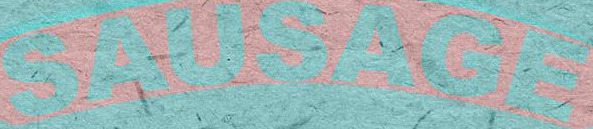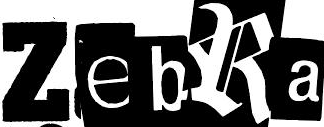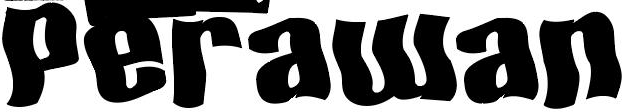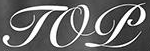Identify the words shown in these images in order, separated by a semicolon. SAUSAGE; ZebRa; Perawan; TOP 